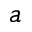<formula> <loc_0><loc_0><loc_500><loc_500>a</formula> 